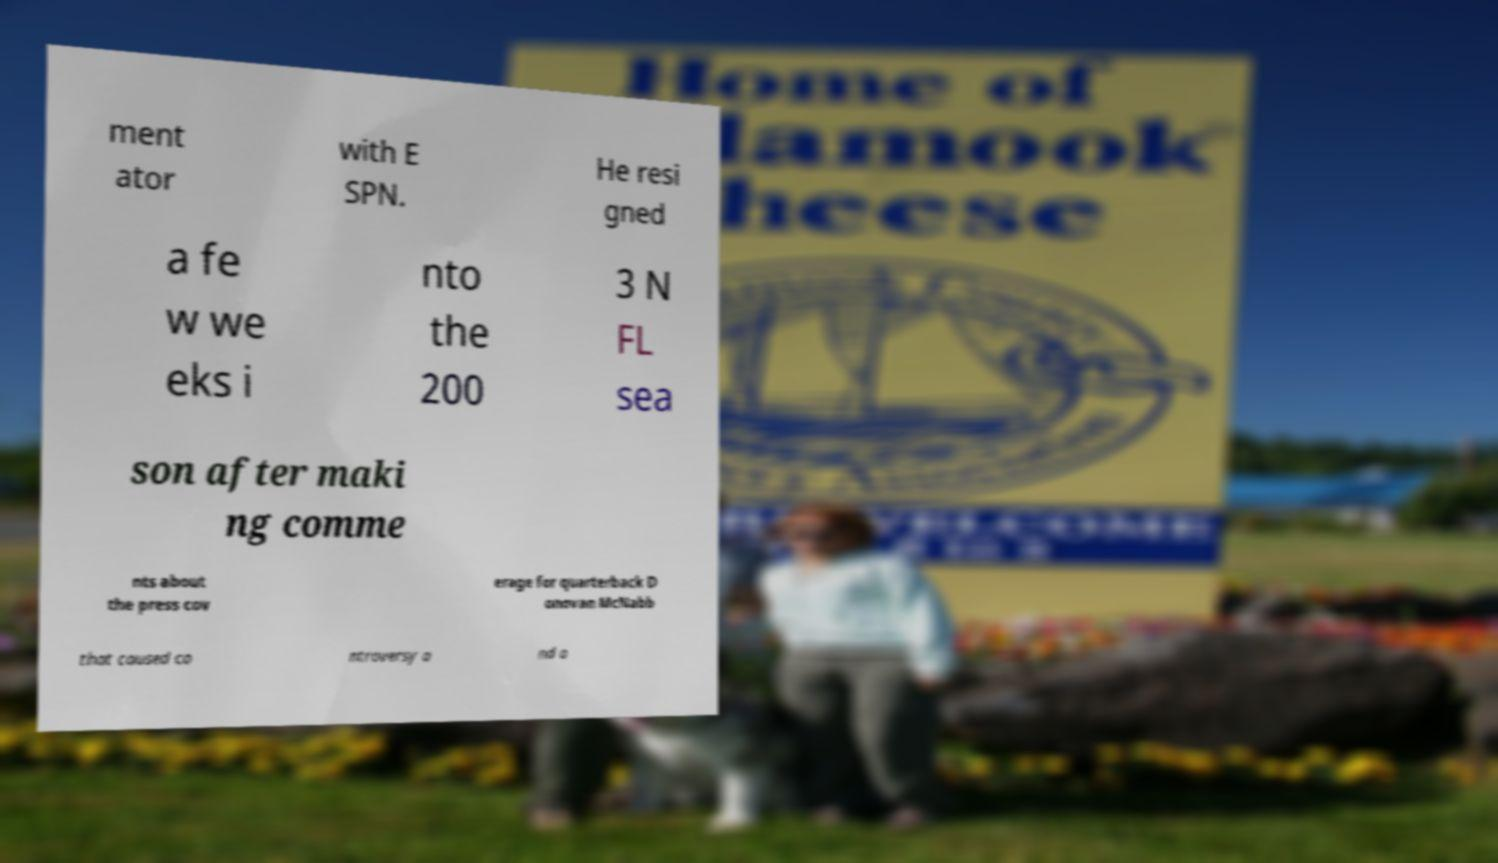Please identify and transcribe the text found in this image. ment ator with E SPN. He resi gned a fe w we eks i nto the 200 3 N FL sea son after maki ng comme nts about the press cov erage for quarterback D onovan McNabb that caused co ntroversy a nd a 